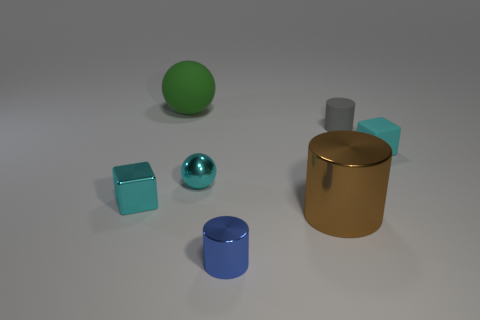Do the big green object and the small cyan block that is left of the blue shiny object have the same material?
Offer a very short reply. No. There is a metal sphere; is its color the same as the small metal object that is in front of the large brown metal cylinder?
Offer a very short reply. No. There is a small object that is left of the blue cylinder and right of the big green rubber thing; what is its color?
Your response must be concise. Cyan. How many large green spheres are behind the big metal cylinder?
Keep it short and to the point. 1. What number of things are tiny cyan metallic spheres or objects in front of the large metallic cylinder?
Keep it short and to the point. 2. Are there any small cylinders left of the block that is on the right side of the tiny blue shiny cylinder?
Give a very brief answer. Yes. What is the color of the small thing that is to the left of the green rubber sphere?
Provide a short and direct response. Cyan. Is the number of gray matte cylinders that are in front of the large rubber ball the same as the number of small spheres?
Provide a short and direct response. Yes. There is a tiny cyan thing that is both right of the green rubber ball and to the left of the small gray object; what is its shape?
Give a very brief answer. Sphere. There is another tiny thing that is the same shape as the blue object; what is its color?
Provide a succinct answer. Gray. 